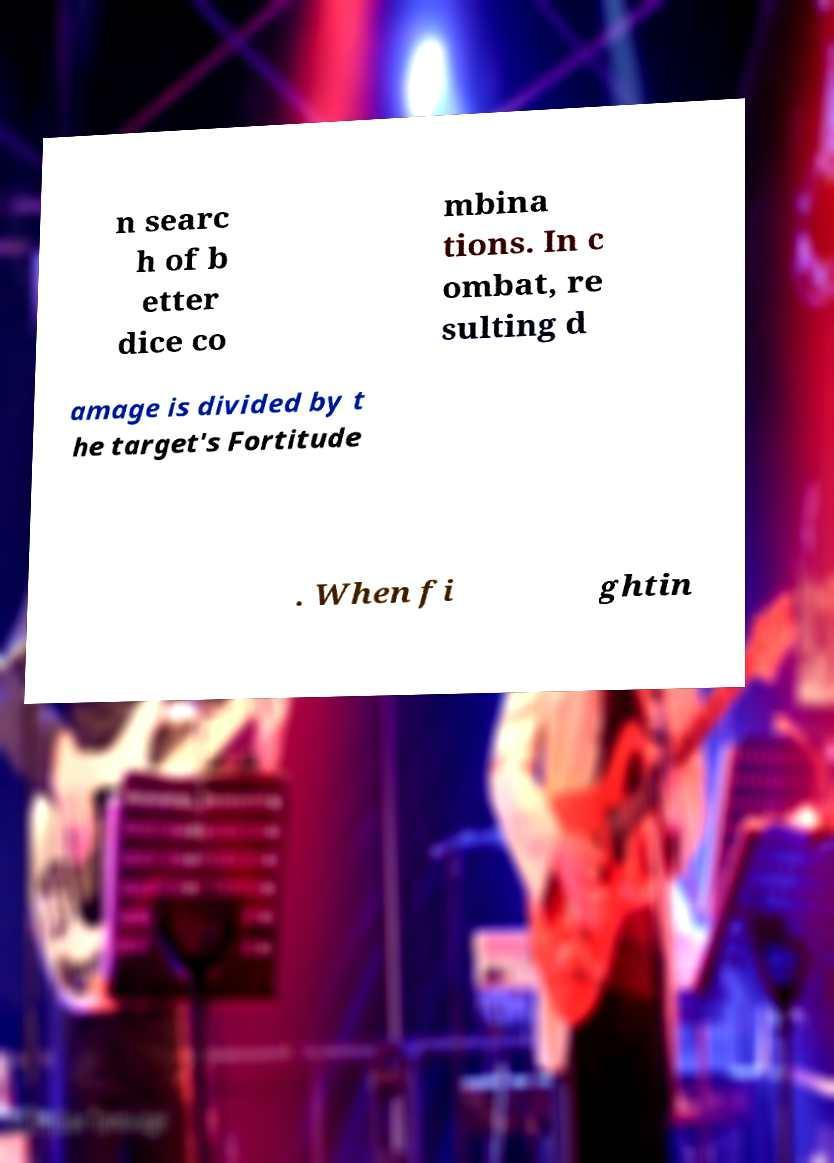Could you assist in decoding the text presented in this image and type it out clearly? n searc h of b etter dice co mbina tions. In c ombat, re sulting d amage is divided by t he target's Fortitude . When fi ghtin 